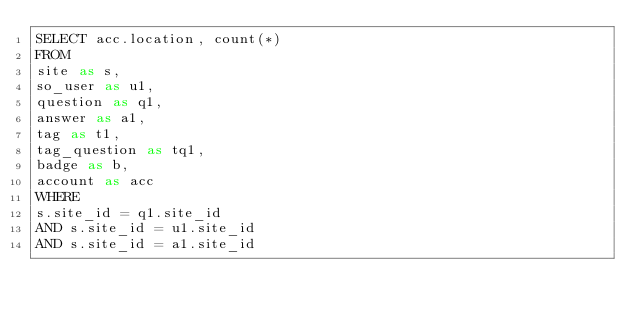<code> <loc_0><loc_0><loc_500><loc_500><_SQL_>SELECT acc.location, count(*)
FROM
site as s,
so_user as u1,
question as q1,
answer as a1,
tag as t1,
tag_question as tq1,
badge as b,
account as acc
WHERE
s.site_id = q1.site_id
AND s.site_id = u1.site_id
AND s.site_id = a1.site_id</code> 